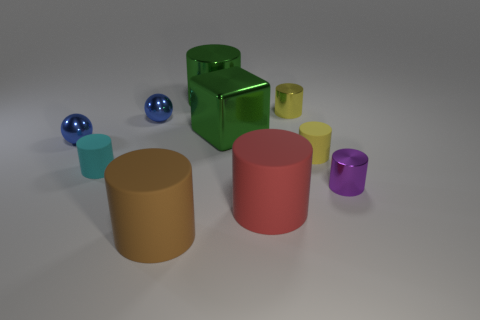Subtract 2 cylinders. How many cylinders are left? 5 Subtract all brown cylinders. How many cylinders are left? 6 Subtract all yellow matte cylinders. How many cylinders are left? 6 Subtract all brown balls. Subtract all red cylinders. How many balls are left? 2 Subtract all cylinders. How many objects are left? 3 Subtract all small brown shiny spheres. Subtract all large green objects. How many objects are left? 8 Add 1 small yellow things. How many small yellow things are left? 3 Add 5 small blue metallic balls. How many small blue metallic balls exist? 7 Subtract 1 red cylinders. How many objects are left? 9 